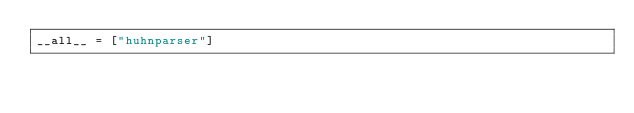<code> <loc_0><loc_0><loc_500><loc_500><_Python_>__all__ = ["huhnparser"]</code> 